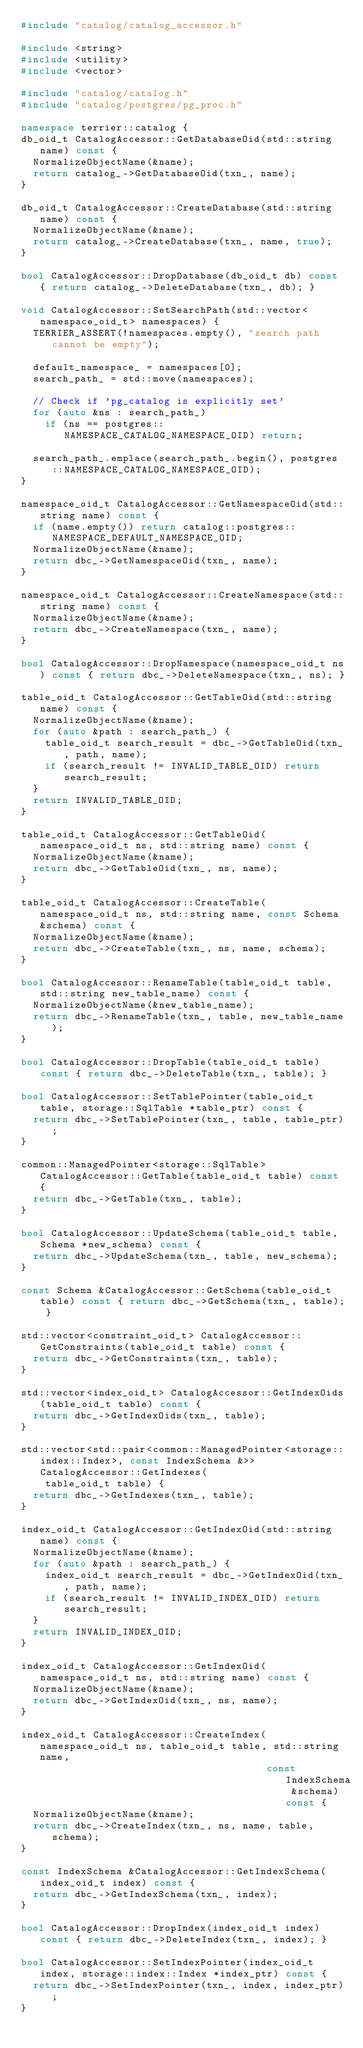Convert code to text. <code><loc_0><loc_0><loc_500><loc_500><_C++_>#include "catalog/catalog_accessor.h"

#include <string>
#include <utility>
#include <vector>

#include "catalog/catalog.h"
#include "catalog/postgres/pg_proc.h"

namespace terrier::catalog {
db_oid_t CatalogAccessor::GetDatabaseOid(std::string name) const {
  NormalizeObjectName(&name);
  return catalog_->GetDatabaseOid(txn_, name);
}

db_oid_t CatalogAccessor::CreateDatabase(std::string name) const {
  NormalizeObjectName(&name);
  return catalog_->CreateDatabase(txn_, name, true);
}

bool CatalogAccessor::DropDatabase(db_oid_t db) const { return catalog_->DeleteDatabase(txn_, db); }

void CatalogAccessor::SetSearchPath(std::vector<namespace_oid_t> namespaces) {
  TERRIER_ASSERT(!namespaces.empty(), "search path cannot be empty");

  default_namespace_ = namespaces[0];
  search_path_ = std::move(namespaces);

  // Check if 'pg_catalog is explicitly set'
  for (auto &ns : search_path_)
    if (ns == postgres::NAMESPACE_CATALOG_NAMESPACE_OID) return;

  search_path_.emplace(search_path_.begin(), postgres::NAMESPACE_CATALOG_NAMESPACE_OID);
}

namespace_oid_t CatalogAccessor::GetNamespaceOid(std::string name) const {
  if (name.empty()) return catalog::postgres::NAMESPACE_DEFAULT_NAMESPACE_OID;
  NormalizeObjectName(&name);
  return dbc_->GetNamespaceOid(txn_, name);
}

namespace_oid_t CatalogAccessor::CreateNamespace(std::string name) const {
  NormalizeObjectName(&name);
  return dbc_->CreateNamespace(txn_, name);
}

bool CatalogAccessor::DropNamespace(namespace_oid_t ns) const { return dbc_->DeleteNamespace(txn_, ns); }

table_oid_t CatalogAccessor::GetTableOid(std::string name) const {
  NormalizeObjectName(&name);
  for (auto &path : search_path_) {
    table_oid_t search_result = dbc_->GetTableOid(txn_, path, name);
    if (search_result != INVALID_TABLE_OID) return search_result;
  }
  return INVALID_TABLE_OID;
}

table_oid_t CatalogAccessor::GetTableOid(namespace_oid_t ns, std::string name) const {
  NormalizeObjectName(&name);
  return dbc_->GetTableOid(txn_, ns, name);
}

table_oid_t CatalogAccessor::CreateTable(namespace_oid_t ns, std::string name, const Schema &schema) const {
  NormalizeObjectName(&name);
  return dbc_->CreateTable(txn_, ns, name, schema);
}

bool CatalogAccessor::RenameTable(table_oid_t table, std::string new_table_name) const {
  NormalizeObjectName(&new_table_name);
  return dbc_->RenameTable(txn_, table, new_table_name);
}

bool CatalogAccessor::DropTable(table_oid_t table) const { return dbc_->DeleteTable(txn_, table); }

bool CatalogAccessor::SetTablePointer(table_oid_t table, storage::SqlTable *table_ptr) const {
  return dbc_->SetTablePointer(txn_, table, table_ptr);
}

common::ManagedPointer<storage::SqlTable> CatalogAccessor::GetTable(table_oid_t table) const {
  return dbc_->GetTable(txn_, table);
}

bool CatalogAccessor::UpdateSchema(table_oid_t table, Schema *new_schema) const {
  return dbc_->UpdateSchema(txn_, table, new_schema);
}

const Schema &CatalogAccessor::GetSchema(table_oid_t table) const { return dbc_->GetSchema(txn_, table); }

std::vector<constraint_oid_t> CatalogAccessor::GetConstraints(table_oid_t table) const {
  return dbc_->GetConstraints(txn_, table);
}

std::vector<index_oid_t> CatalogAccessor::GetIndexOids(table_oid_t table) const {
  return dbc_->GetIndexOids(txn_, table);
}

std::vector<std::pair<common::ManagedPointer<storage::index::Index>, const IndexSchema &>> CatalogAccessor::GetIndexes(
    table_oid_t table) {
  return dbc_->GetIndexes(txn_, table);
}

index_oid_t CatalogAccessor::GetIndexOid(std::string name) const {
  NormalizeObjectName(&name);
  for (auto &path : search_path_) {
    index_oid_t search_result = dbc_->GetIndexOid(txn_, path, name);
    if (search_result != INVALID_INDEX_OID) return search_result;
  }
  return INVALID_INDEX_OID;
}

index_oid_t CatalogAccessor::GetIndexOid(namespace_oid_t ns, std::string name) const {
  NormalizeObjectName(&name);
  return dbc_->GetIndexOid(txn_, ns, name);
}

index_oid_t CatalogAccessor::CreateIndex(namespace_oid_t ns, table_oid_t table, std::string name,
                                         const IndexSchema &schema) const {
  NormalizeObjectName(&name);
  return dbc_->CreateIndex(txn_, ns, name, table, schema);
}

const IndexSchema &CatalogAccessor::GetIndexSchema(index_oid_t index) const {
  return dbc_->GetIndexSchema(txn_, index);
}

bool CatalogAccessor::DropIndex(index_oid_t index) const { return dbc_->DeleteIndex(txn_, index); }

bool CatalogAccessor::SetIndexPointer(index_oid_t index, storage::index::Index *index_ptr) const {
  return dbc_->SetIndexPointer(txn_, index, index_ptr);
}
</code> 